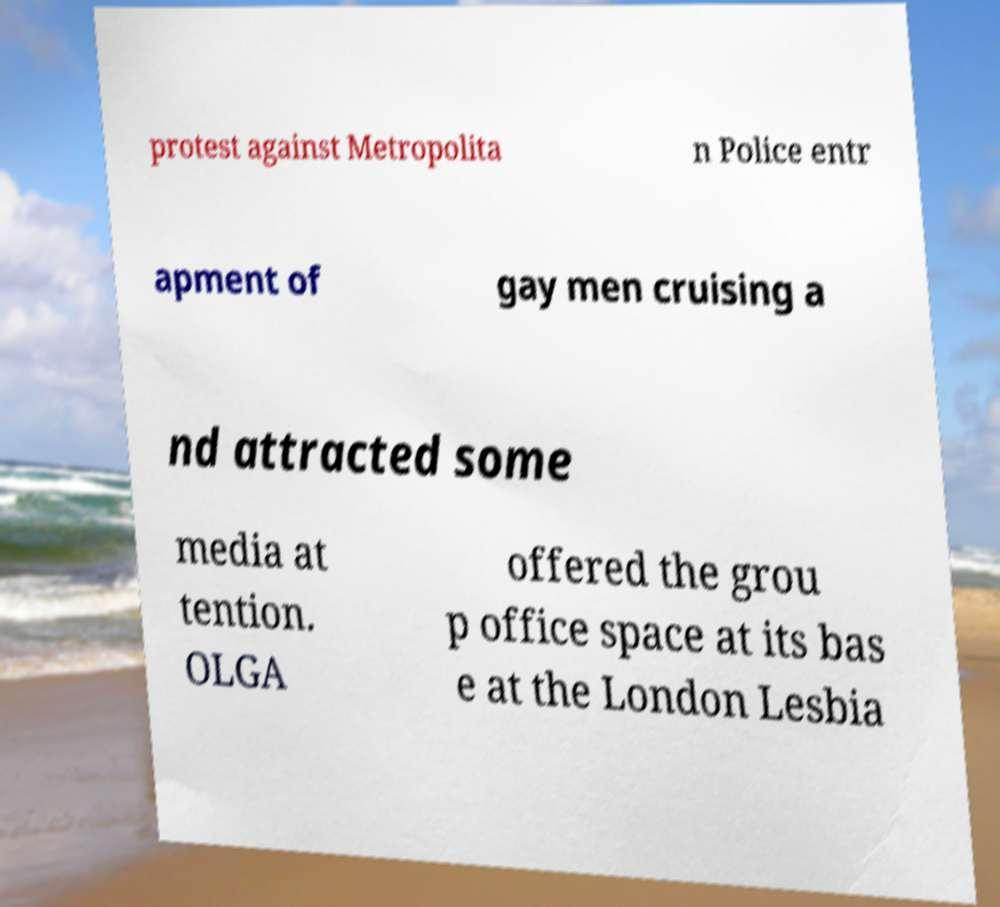What messages or text are displayed in this image? I need them in a readable, typed format. protest against Metropolita n Police entr apment of gay men cruising a nd attracted some media at tention. OLGA offered the grou p office space at its bas e at the London Lesbia 